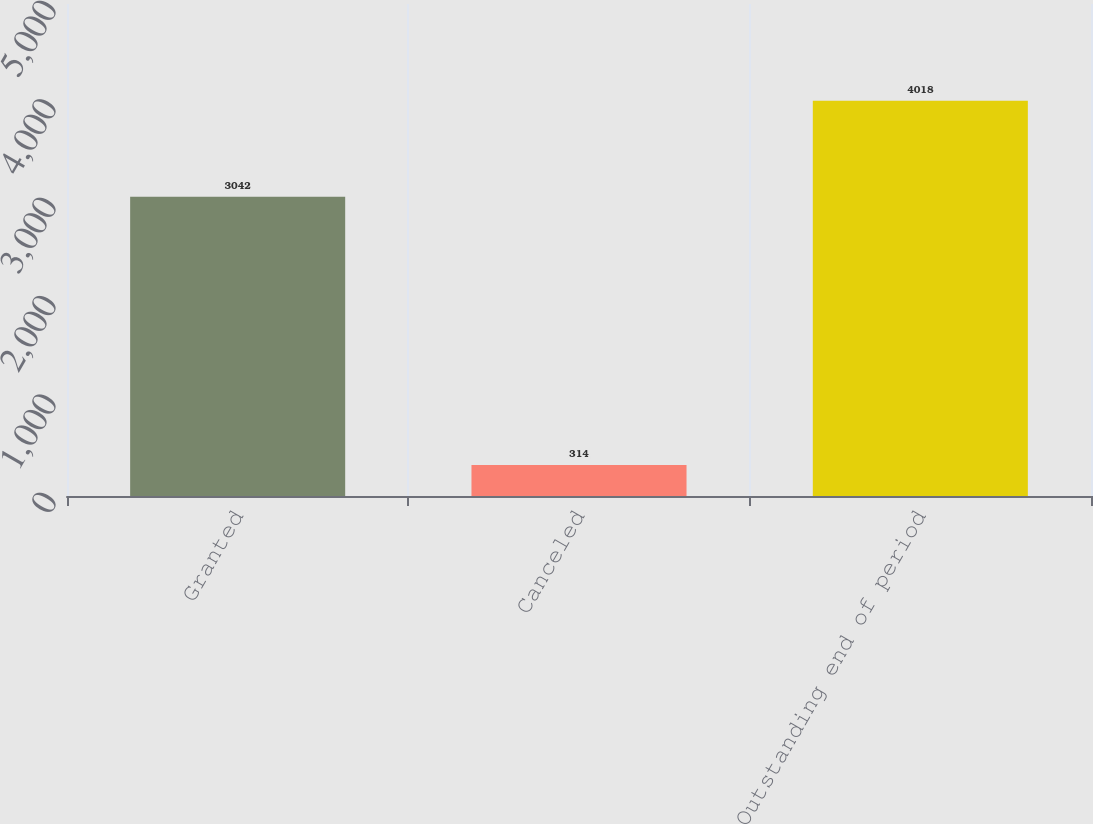Convert chart to OTSL. <chart><loc_0><loc_0><loc_500><loc_500><bar_chart><fcel>Granted<fcel>Canceled<fcel>Outstanding end of period<nl><fcel>3042<fcel>314<fcel>4018<nl></chart> 